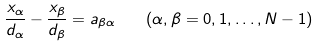Convert formula to latex. <formula><loc_0><loc_0><loc_500><loc_500>\frac { x _ { \alpha } } { d _ { \alpha } } - \frac { x _ { \beta } } { d _ { \beta } } = a _ { \beta \alpha } \quad ( \alpha , \beta = 0 , 1 , \dots , N - 1 )</formula> 